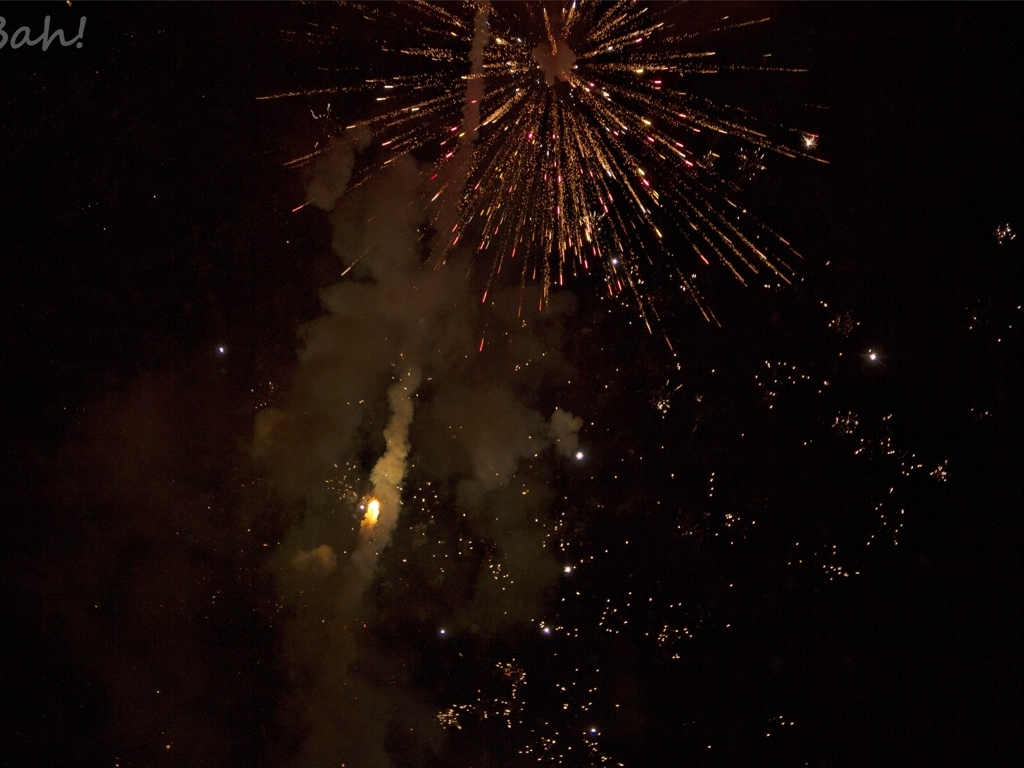What celebration could this image depict? The image captures a dazzling display of fireworks, which could indicate a celebration of a major holiday or event, such as New Year's Eve, Independence Day, or a festive public gathering. How would you describe the colors in the fireworks? The fireworks display a variety of colors ranging from warm golden and reddish hues to cooler shades of blue and white, creating a vibrant contrast against the night sky. 